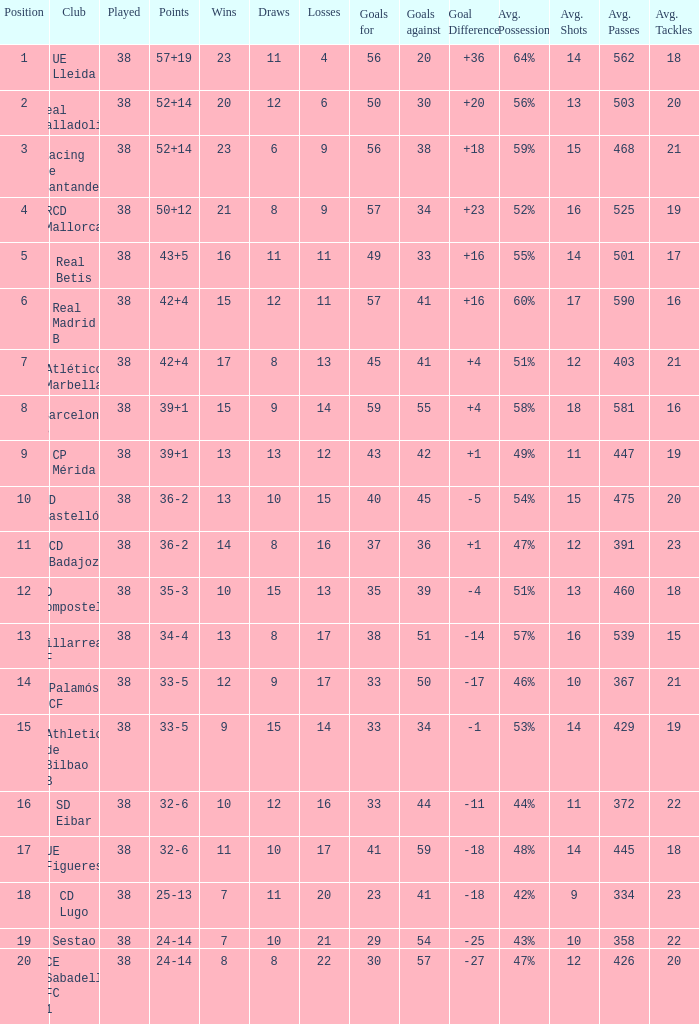What is the average goal difference with 51 goals scored against and less than 17 losses? None. 